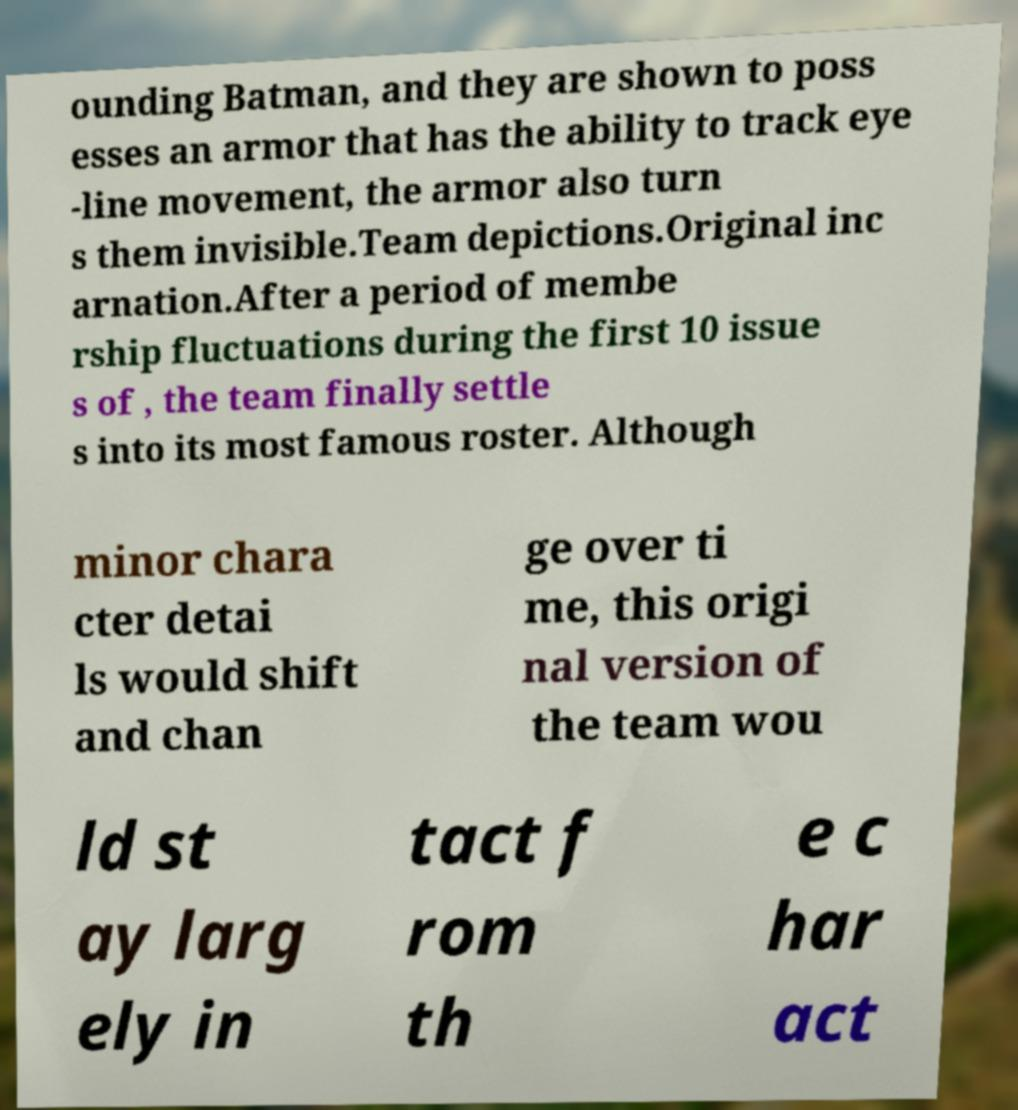What messages or text are displayed in this image? I need them in a readable, typed format. ounding Batman, and they are shown to poss esses an armor that has the ability to track eye -line movement, the armor also turn s them invisible.Team depictions.Original inc arnation.After a period of membe rship fluctuations during the first 10 issue s of , the team finally settle s into its most famous roster. Although minor chara cter detai ls would shift and chan ge over ti me, this origi nal version of the team wou ld st ay larg ely in tact f rom th e c har act 